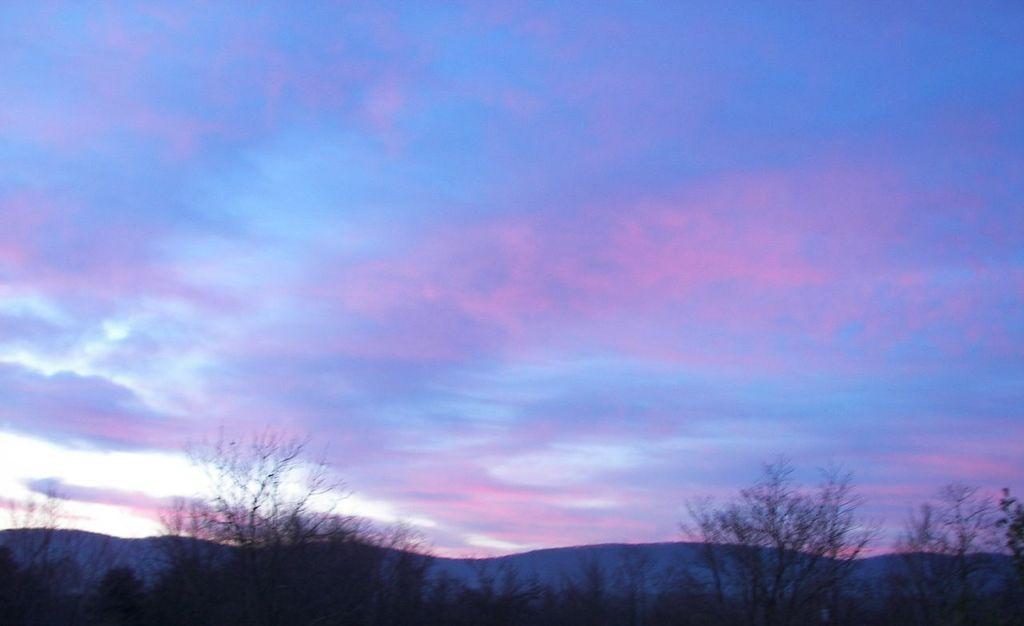Describe this image in one or two sentences. In this image I can see number of trees, clouds and the sky. 